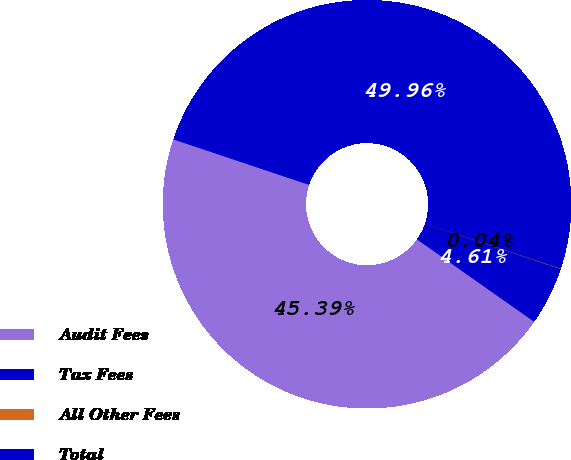Convert chart to OTSL. <chart><loc_0><loc_0><loc_500><loc_500><pie_chart><fcel>Audit Fees<fcel>Tax Fees<fcel>All Other Fees<fcel>Total<nl><fcel>45.39%<fcel>4.61%<fcel>0.04%<fcel>49.96%<nl></chart> 